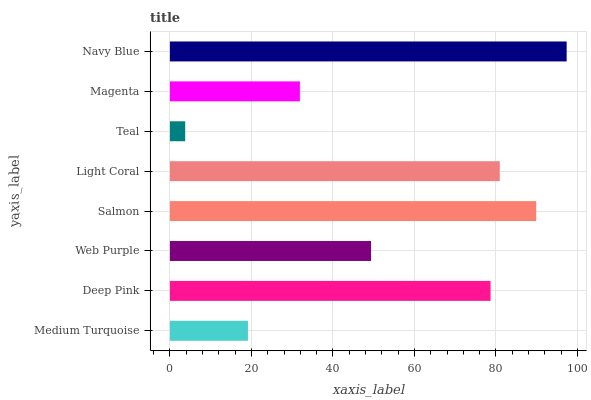Is Teal the minimum?
Answer yes or no. Yes. Is Navy Blue the maximum?
Answer yes or no. Yes. Is Deep Pink the minimum?
Answer yes or no. No. Is Deep Pink the maximum?
Answer yes or no. No. Is Deep Pink greater than Medium Turquoise?
Answer yes or no. Yes. Is Medium Turquoise less than Deep Pink?
Answer yes or no. Yes. Is Medium Turquoise greater than Deep Pink?
Answer yes or no. No. Is Deep Pink less than Medium Turquoise?
Answer yes or no. No. Is Deep Pink the high median?
Answer yes or no. Yes. Is Web Purple the low median?
Answer yes or no. Yes. Is Teal the high median?
Answer yes or no. No. Is Salmon the low median?
Answer yes or no. No. 